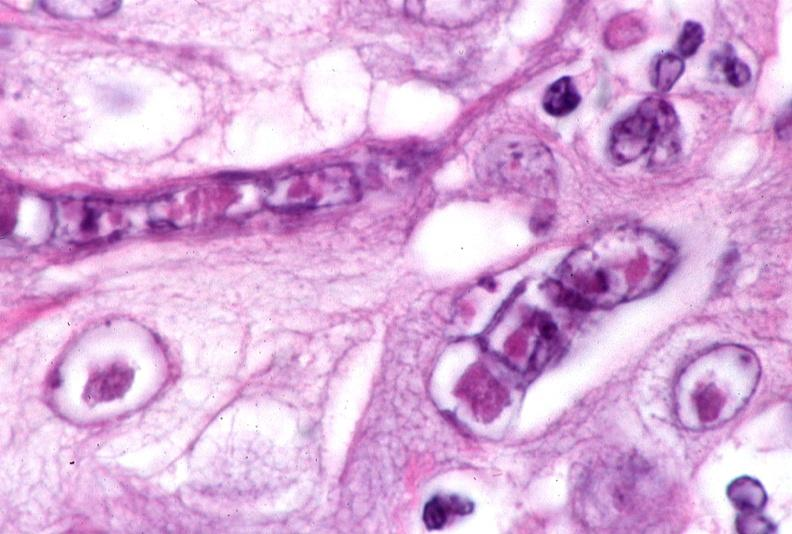where is this?
Answer the question using a single word or phrase. Skin 